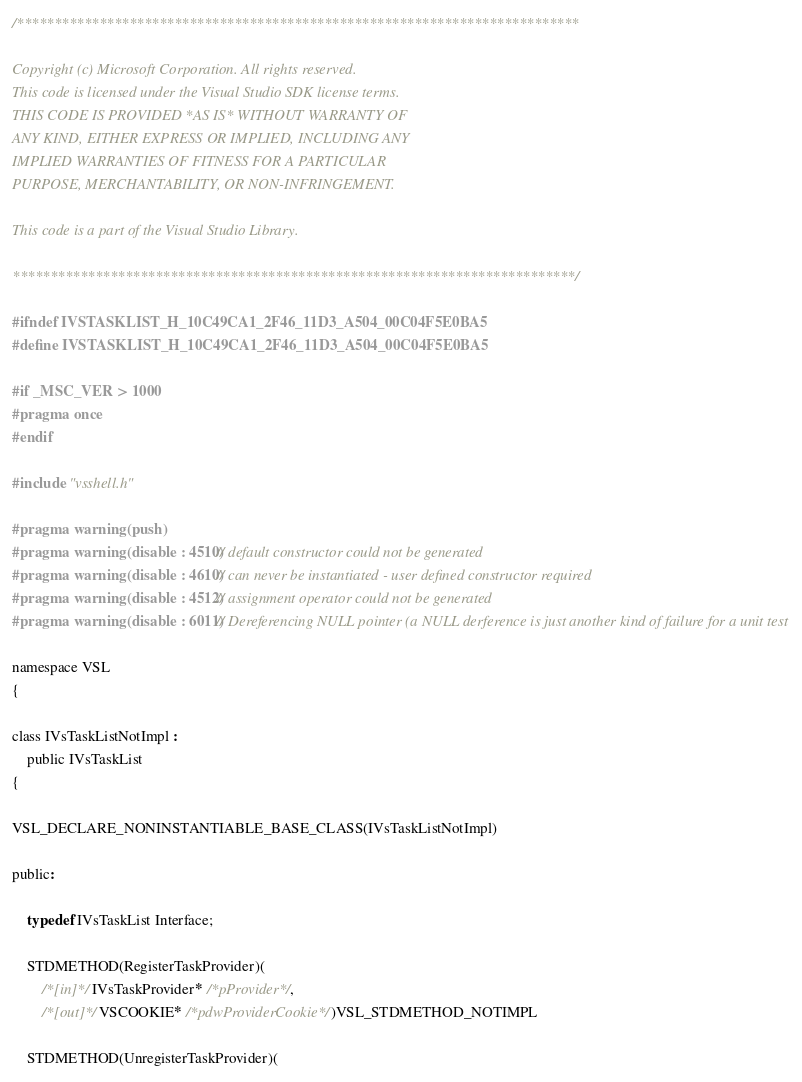Convert code to text. <code><loc_0><loc_0><loc_500><loc_500><_C_>/***************************************************************************

Copyright (c) Microsoft Corporation. All rights reserved.
This code is licensed under the Visual Studio SDK license terms.
THIS CODE IS PROVIDED *AS IS* WITHOUT WARRANTY OF
ANY KIND, EITHER EXPRESS OR IMPLIED, INCLUDING ANY
IMPLIED WARRANTIES OF FITNESS FOR A PARTICULAR
PURPOSE, MERCHANTABILITY, OR NON-INFRINGEMENT.

This code is a part of the Visual Studio Library.

***************************************************************************/

#ifndef IVSTASKLIST_H_10C49CA1_2F46_11D3_A504_00C04F5E0BA5
#define IVSTASKLIST_H_10C49CA1_2F46_11D3_A504_00C04F5E0BA5

#if _MSC_VER > 1000
#pragma once
#endif

#include "vsshell.h"

#pragma warning(push)
#pragma warning(disable : 4510) // default constructor could not be generated
#pragma warning(disable : 4610) // can never be instantiated - user defined constructor required
#pragma warning(disable : 4512) // assignment operator could not be generated
#pragma warning(disable : 6011) // Dereferencing NULL pointer (a NULL derference is just another kind of failure for a unit test

namespace VSL
{

class IVsTaskListNotImpl :
	public IVsTaskList
{

VSL_DECLARE_NONINSTANTIABLE_BASE_CLASS(IVsTaskListNotImpl)

public:

	typedef IVsTaskList Interface;

	STDMETHOD(RegisterTaskProvider)(
		/*[in]*/ IVsTaskProvider* /*pProvider*/,
		/*[out]*/ VSCOOKIE* /*pdwProviderCookie*/)VSL_STDMETHOD_NOTIMPL

	STDMETHOD(UnregisterTaskProvider)(</code> 